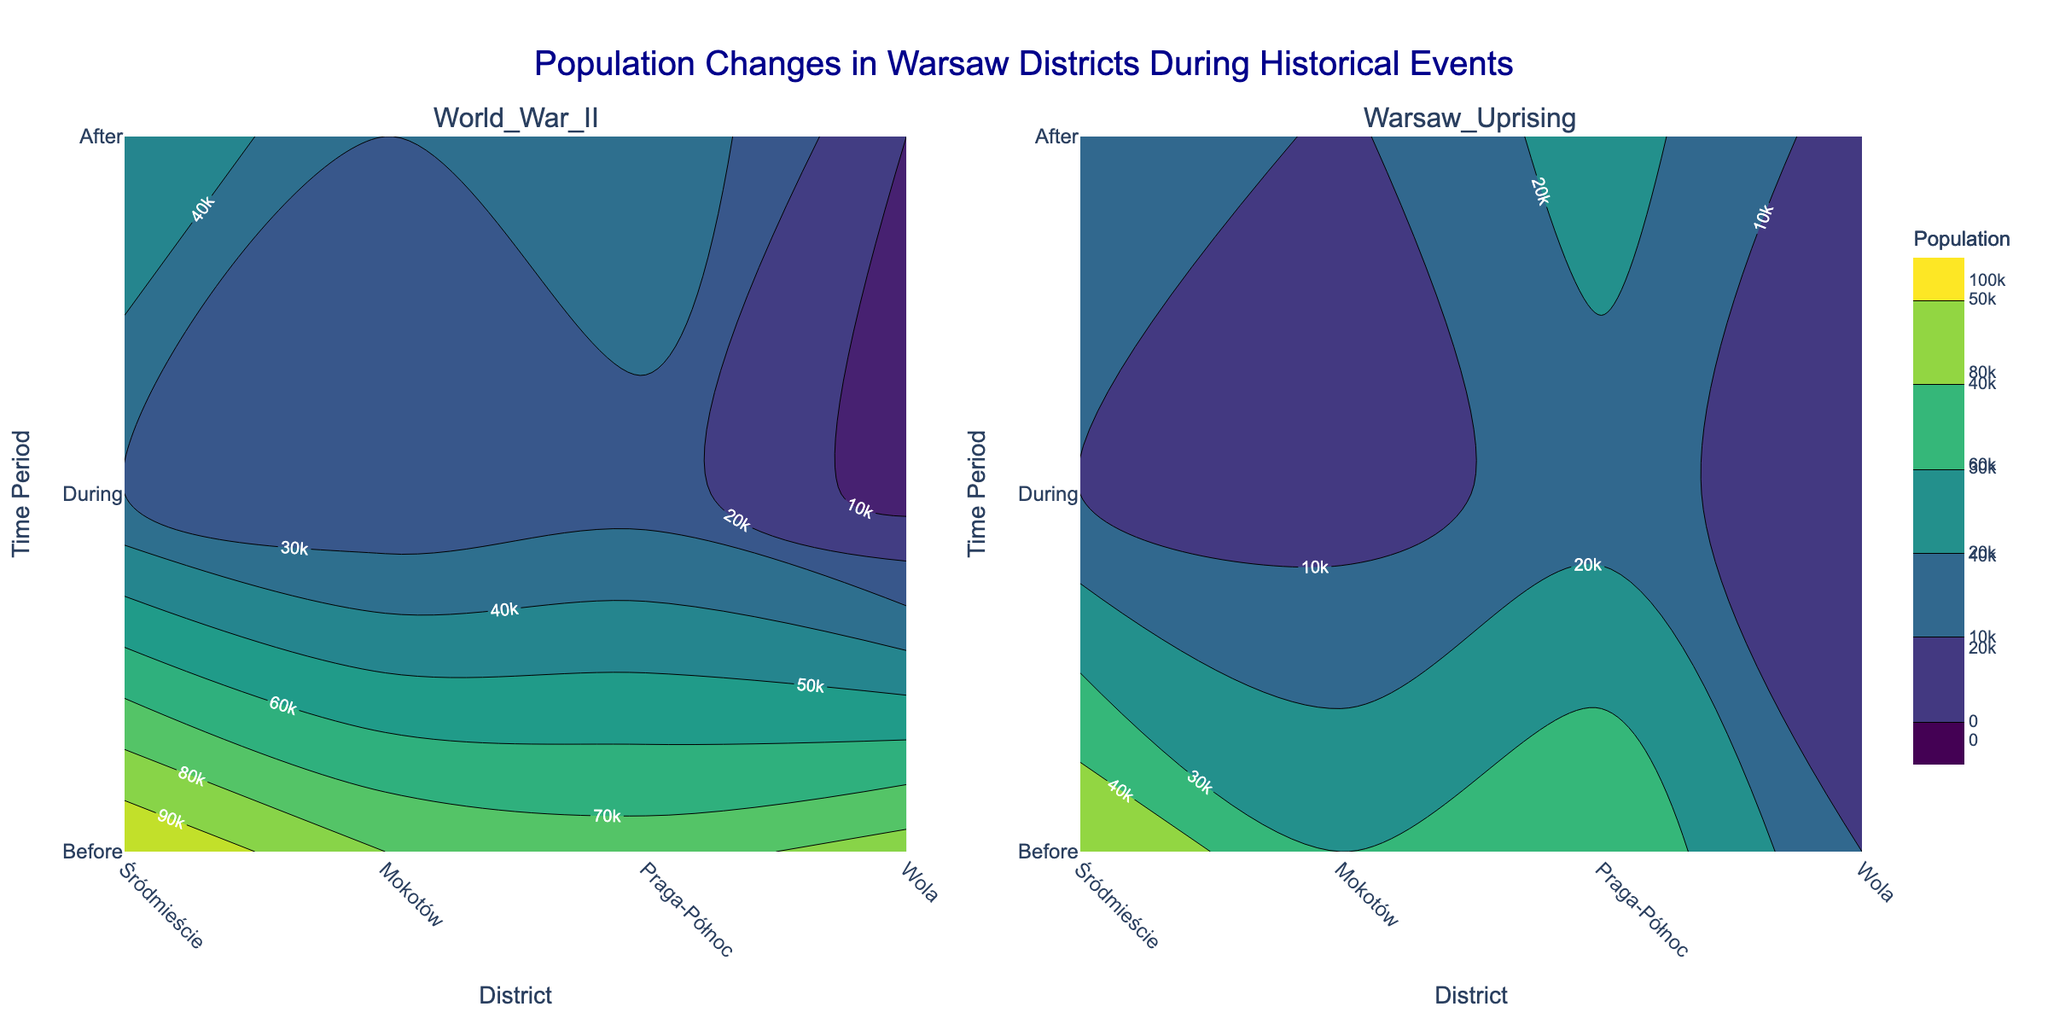How does the population in Śródmieście change during World War II? The contour plot for World War II shows the population in Śródmieście. Before the event, the population is around 100,000. During World War II, it drops significantly to about 30,000 and then rises to 50,000 after the event.
Answer: The population decreased from 100,000 to 30,000 during the war and increased to 50,000 after What district experienced the least population during the Warsaw Uprising? By looking at the Warsaw Uprising contour plot, it's evident that Wola had the least population count, with a significant drop during the event. Before the uprising, it was 10,000, which then reduced to 2,000 during the event, and after it was around 5,000.
Answer: Wola What's the difference in the population of Mokotów during World War II and the Warsaw Uprising? To find the difference, we look at the population during the events for Mokotów. During World War II, the population was 20,000, and during the Warsaw Uprising, it was 5,000. The difference is 20,000 - 5,000.
Answer: 15,000 Which period shows a higher population in Praga-Północ during World War II or the Warsaw Uprising? Compare the contour plots for Praga-Północ between the two events. During World War II, the population was 25,000 while during the Warsaw Uprising it was 15,000.
Answer: World War II During which event did Wola see the largest relative decrease in population? By examining both contour plots, Wola's population dropped from 85,000 to 5,000 during World War II, a massive decrease. During the Warsaw Uprising, it dropped from 10,000 to 2,000 which is smaller in absolute and relative terms compared to the World War II drop.
Answer: World War II Which district saw the smallest change in population after World War II compared to population before the event? Compare the populations before and after World War II: Śródmieście (100,000 to 50,000), Mokotów (80,000 to 30,000), Praga-Północ (75,000 to 40,000), Wola (85,000 to 10,000). Praga-Północ saw the smallest absolute change (35,000).
Answer: Praga-Północ 